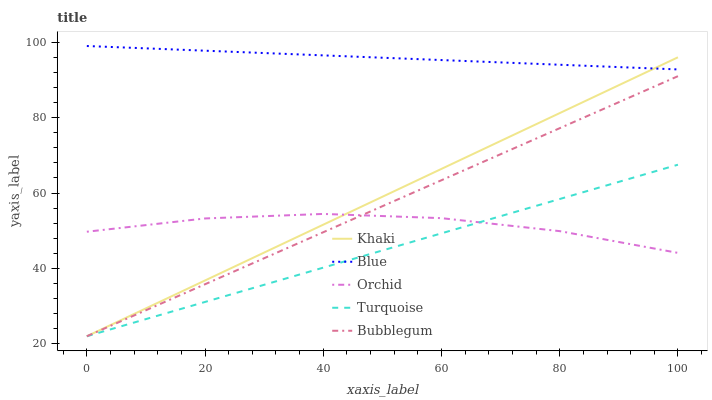Does Turquoise have the minimum area under the curve?
Answer yes or no. Yes. Does Blue have the maximum area under the curve?
Answer yes or no. Yes. Does Khaki have the minimum area under the curve?
Answer yes or no. No. Does Khaki have the maximum area under the curve?
Answer yes or no. No. Is Bubblegum the smoothest?
Answer yes or no. Yes. Is Orchid the roughest?
Answer yes or no. Yes. Is Turquoise the smoothest?
Answer yes or no. No. Is Turquoise the roughest?
Answer yes or no. No. Does Turquoise have the lowest value?
Answer yes or no. Yes. Does Orchid have the lowest value?
Answer yes or no. No. Does Blue have the highest value?
Answer yes or no. Yes. Does Turquoise have the highest value?
Answer yes or no. No. Is Turquoise less than Blue?
Answer yes or no. Yes. Is Blue greater than Bubblegum?
Answer yes or no. Yes. Does Blue intersect Khaki?
Answer yes or no. Yes. Is Blue less than Khaki?
Answer yes or no. No. Is Blue greater than Khaki?
Answer yes or no. No. Does Turquoise intersect Blue?
Answer yes or no. No. 